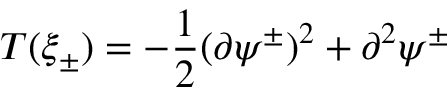<formula> <loc_0><loc_0><loc_500><loc_500>T ( \xi _ { \pm } ) = - \frac { 1 } { 2 } ( \partial \psi ^ { \pm } ) ^ { 2 } + \partial ^ { 2 } \psi ^ { \pm }</formula> 